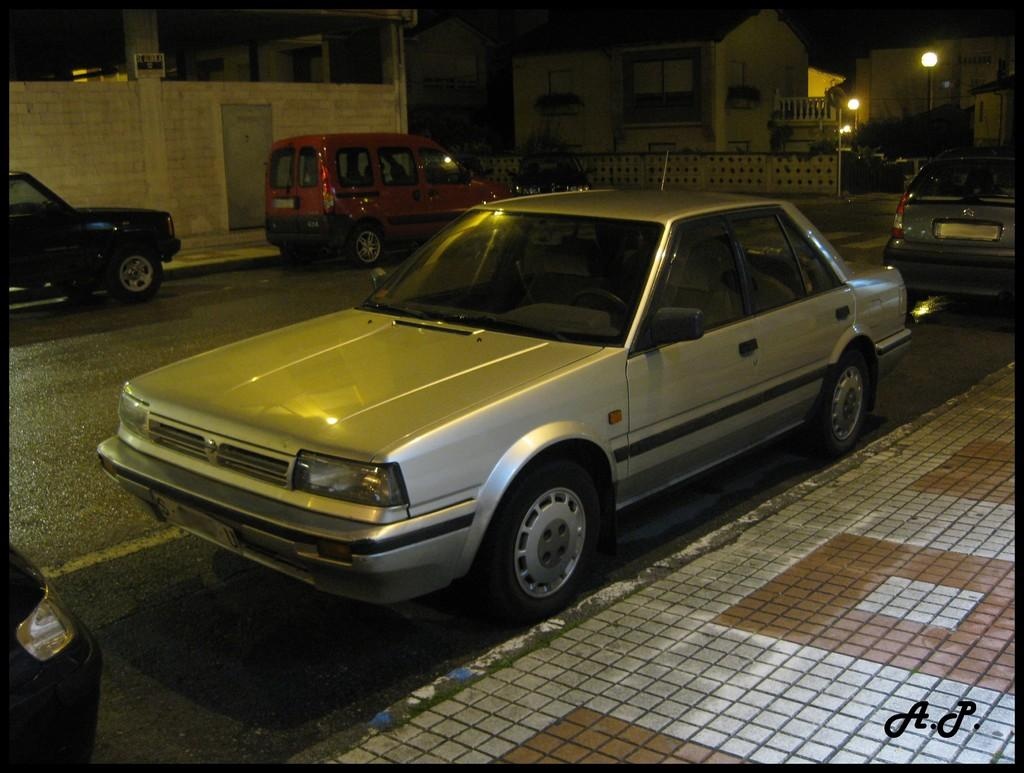What can be seen on both sides of the road in the image? There are vehicles parked on both sides of the road. What structures are visible in the image? There are buildings visible in the image. What type of lighting is present in the image? There are pole lights in the image. What is available for pedestrians to walk on in the image? There is a sidewalk on both sides of the road. Can you see a goat grazing on the sidewalk in the image? No, there is no goat present in the image. What type of knee injury can be seen in the image? There is no knee injury visible in the image. 